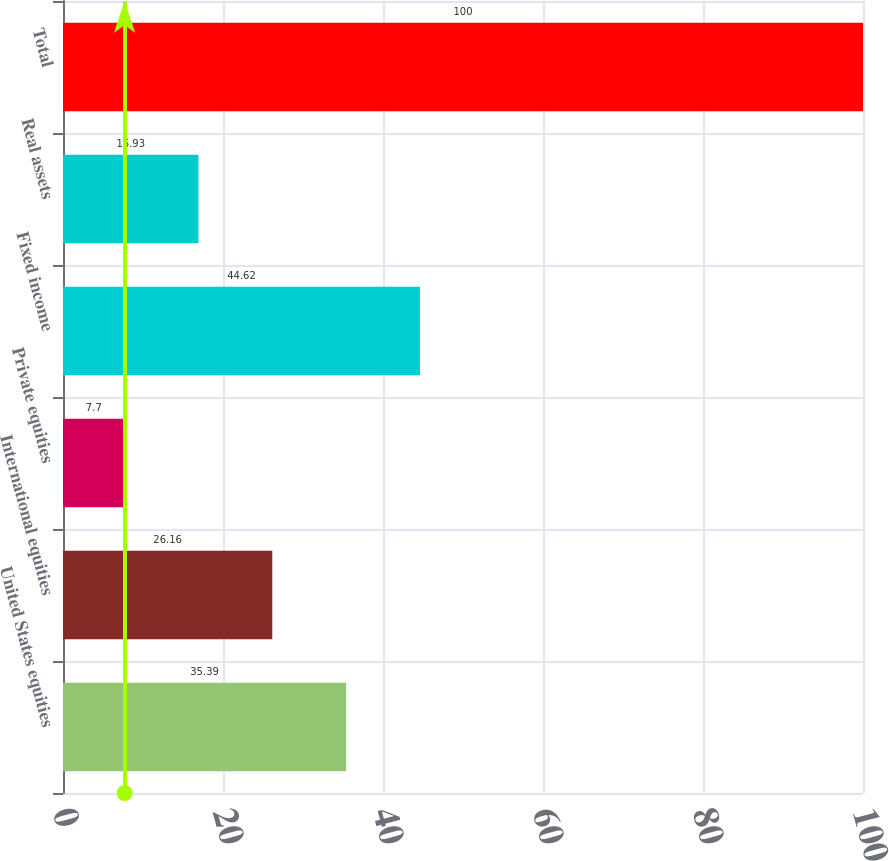Convert chart to OTSL. <chart><loc_0><loc_0><loc_500><loc_500><bar_chart><fcel>United States equities<fcel>International equities<fcel>Private equities<fcel>Fixed income<fcel>Real assets<fcel>Total<nl><fcel>35.39<fcel>26.16<fcel>7.7<fcel>44.62<fcel>16.93<fcel>100<nl></chart> 